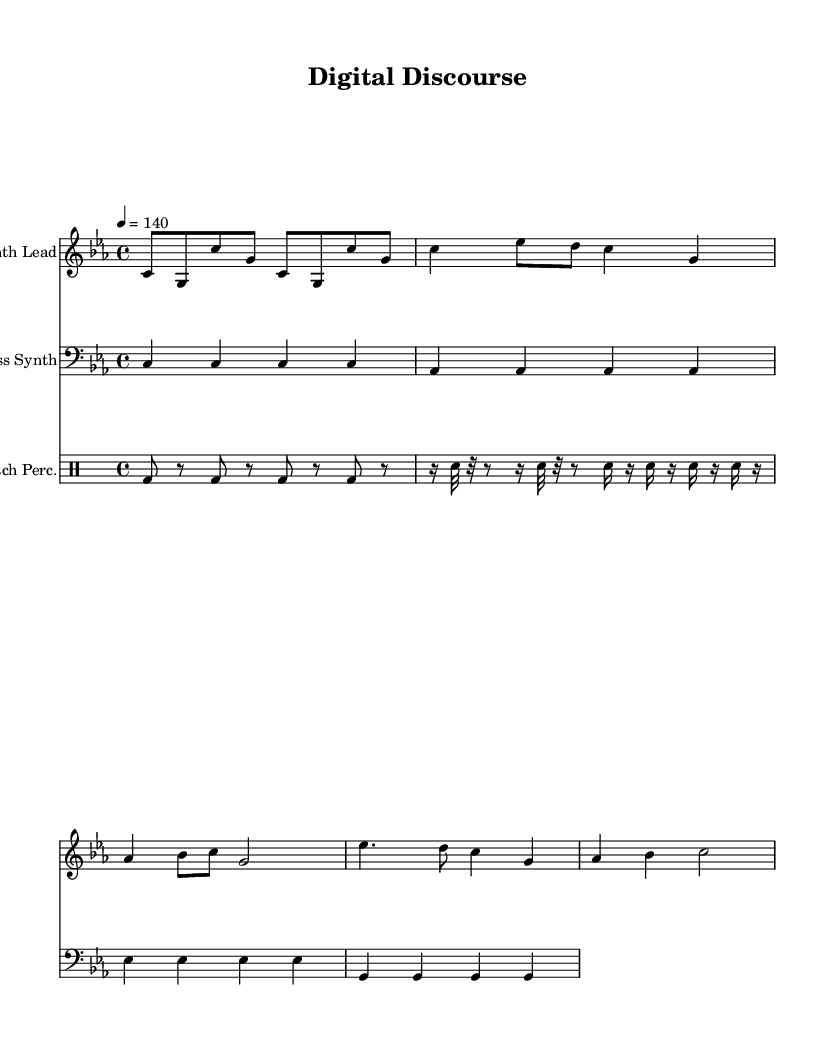What is the title of this composition? The title can be found in the header section of the code where it states "Digital Discourse."
Answer: Digital Discourse What is the key signature of this music? In the global section of the code, it states "\key c \minor," indicating that the piece is in C minor.
Answer: C minor What is the time signature of this music? The time signature is specified in the global section as "\time 4/4," meaning there are four beats per measure.
Answer: 4/4 What is the tempo marking in this piece? The tempo marking is found in the global section as "\tempo 4 = 140," which indicates the speed at which to play the piece.
Answer: 140 How many measures does the synth lead section have? By analyzing the synth lead section, we can count the measures: there are a total of 8 measures indicated by the sets of bars.
Answer: 8 Which instrument plays the bassline in this composition? The instrument responsible for the bassline is specified in the code with "Bass Synth" under the respective staff assignment.
Answer: Bass Synth What rhythmic elements characterize the glitch percussion? In the drummode section, the rhythmic pattern includes a mix of bass drums and snare hits, especially punctuated by the use of "sn" indicating snare, creating a glitchy feel.
Answer: Glitchy elements 